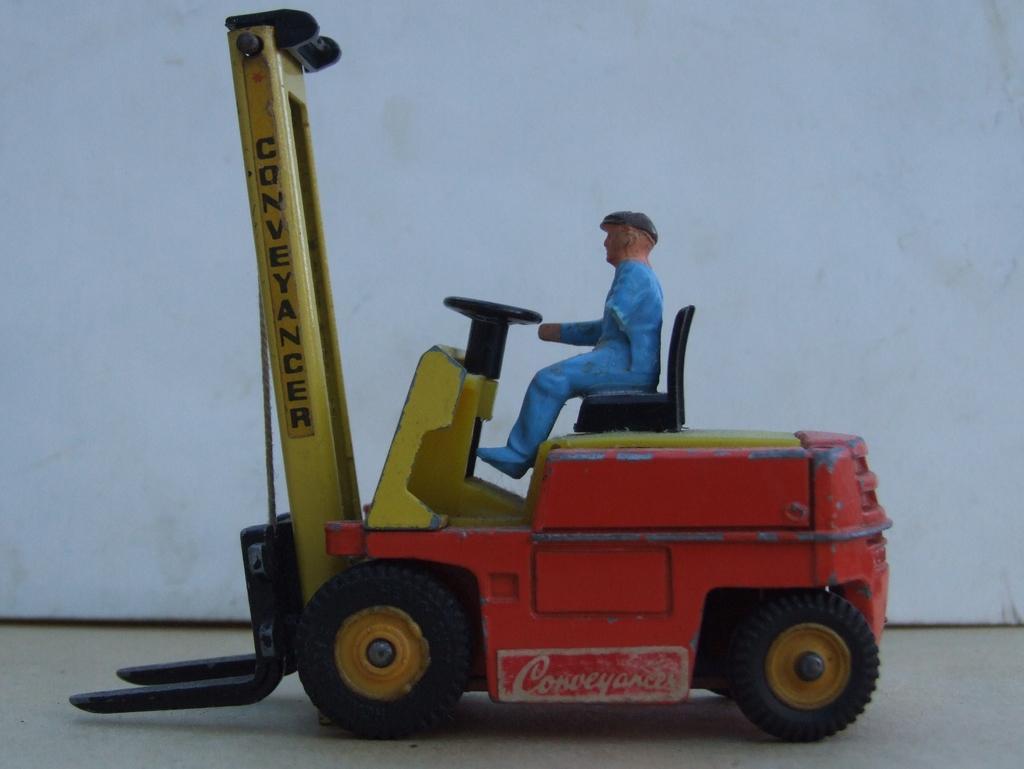Describe this image in one or two sentences. In this picture I can see miniature and I can see white color background. 